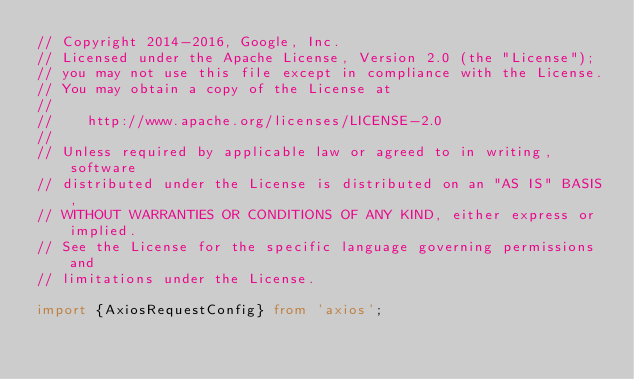<code> <loc_0><loc_0><loc_500><loc_500><_TypeScript_>// Copyright 2014-2016, Google, Inc.
// Licensed under the Apache License, Version 2.0 (the "License");
// you may not use this file except in compliance with the License.
// You may obtain a copy of the License at
//
//    http://www.apache.org/licenses/LICENSE-2.0
//
// Unless required by applicable law or agreed to in writing, software
// distributed under the License is distributed on an "AS IS" BASIS,
// WITHOUT WARRANTIES OR CONDITIONS OF ANY KIND, either express or implied.
// See the License for the specific language governing permissions and
// limitations under the License.

import {AxiosRequestConfig} from 'axios';</code> 